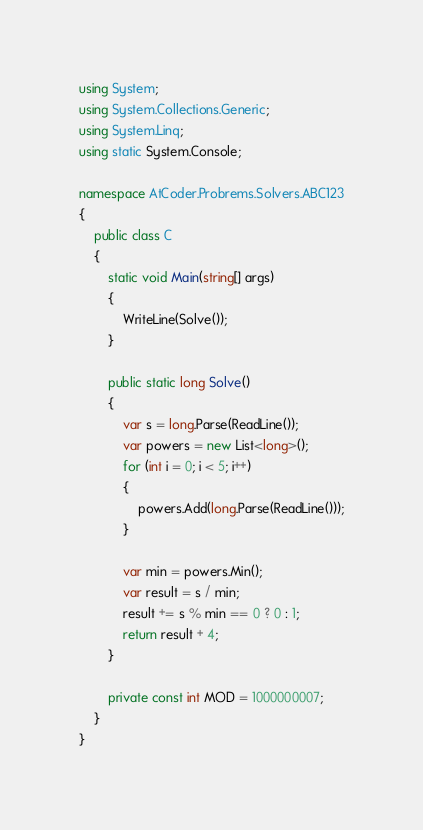Convert code to text. <code><loc_0><loc_0><loc_500><loc_500><_C#_>using System;
using System.Collections.Generic;
using System.Linq;
using static System.Console;

namespace AtCoder.Probrems.Solvers.ABC123
{
    public class C
    {
        static void Main(string[] args)
        {
            WriteLine(Solve());
        }

        public static long Solve()
        {
            var s = long.Parse(ReadLine());
            var powers = new List<long>();
            for (int i = 0; i < 5; i++)
            {
                powers.Add(long.Parse(ReadLine()));
            }

            var min = powers.Min();
            var result = s / min;
            result += s % min == 0 ? 0 : 1;
            return result + 4;
        }

        private const int MOD = 1000000007;
    }
}
</code> 